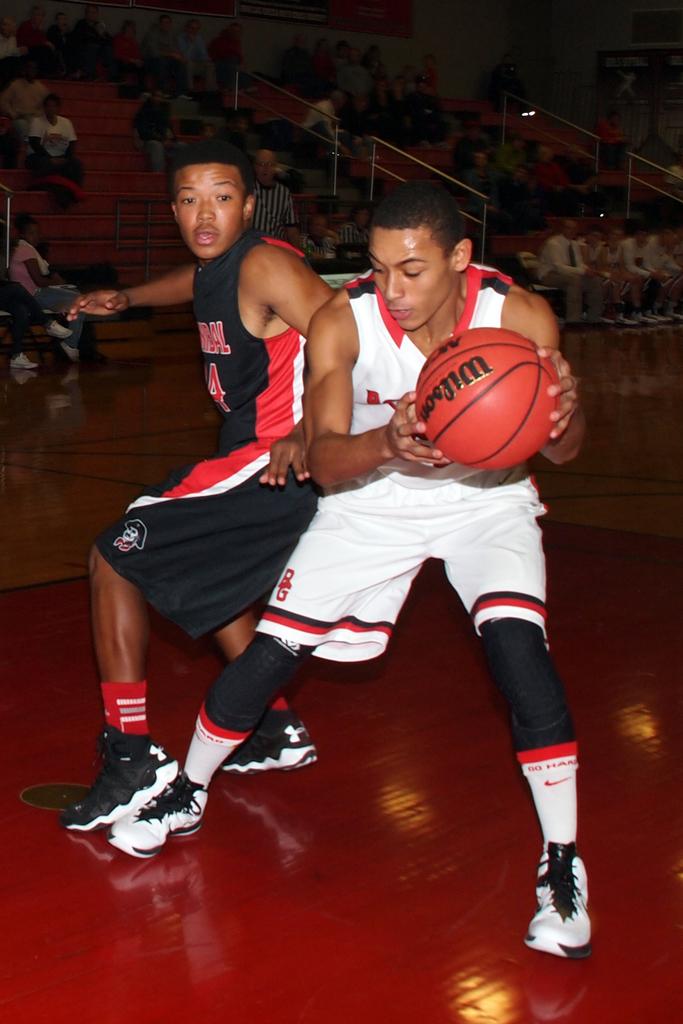What brand is the basketball?
Provide a succinct answer. Wilson. 